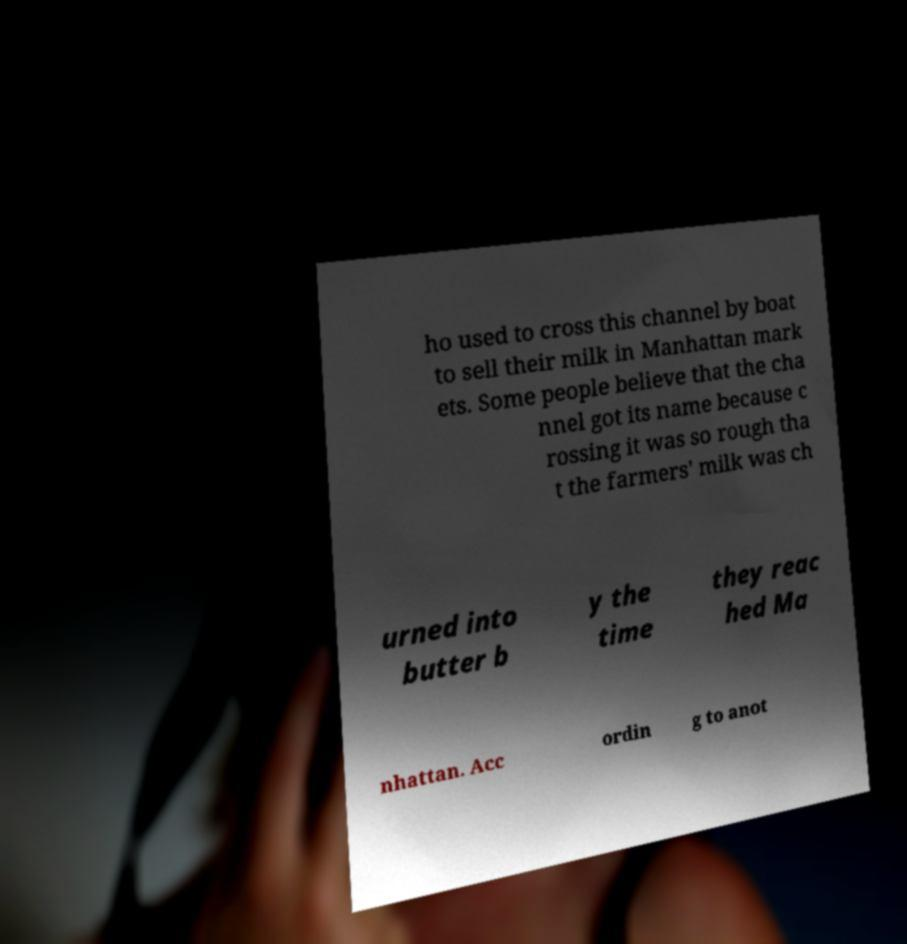I need the written content from this picture converted into text. Can you do that? ho used to cross this channel by boat to sell their milk in Manhattan mark ets. Some people believe that the cha nnel got its name because c rossing it was so rough tha t the farmers' milk was ch urned into butter b y the time they reac hed Ma nhattan. Acc ordin g to anot 